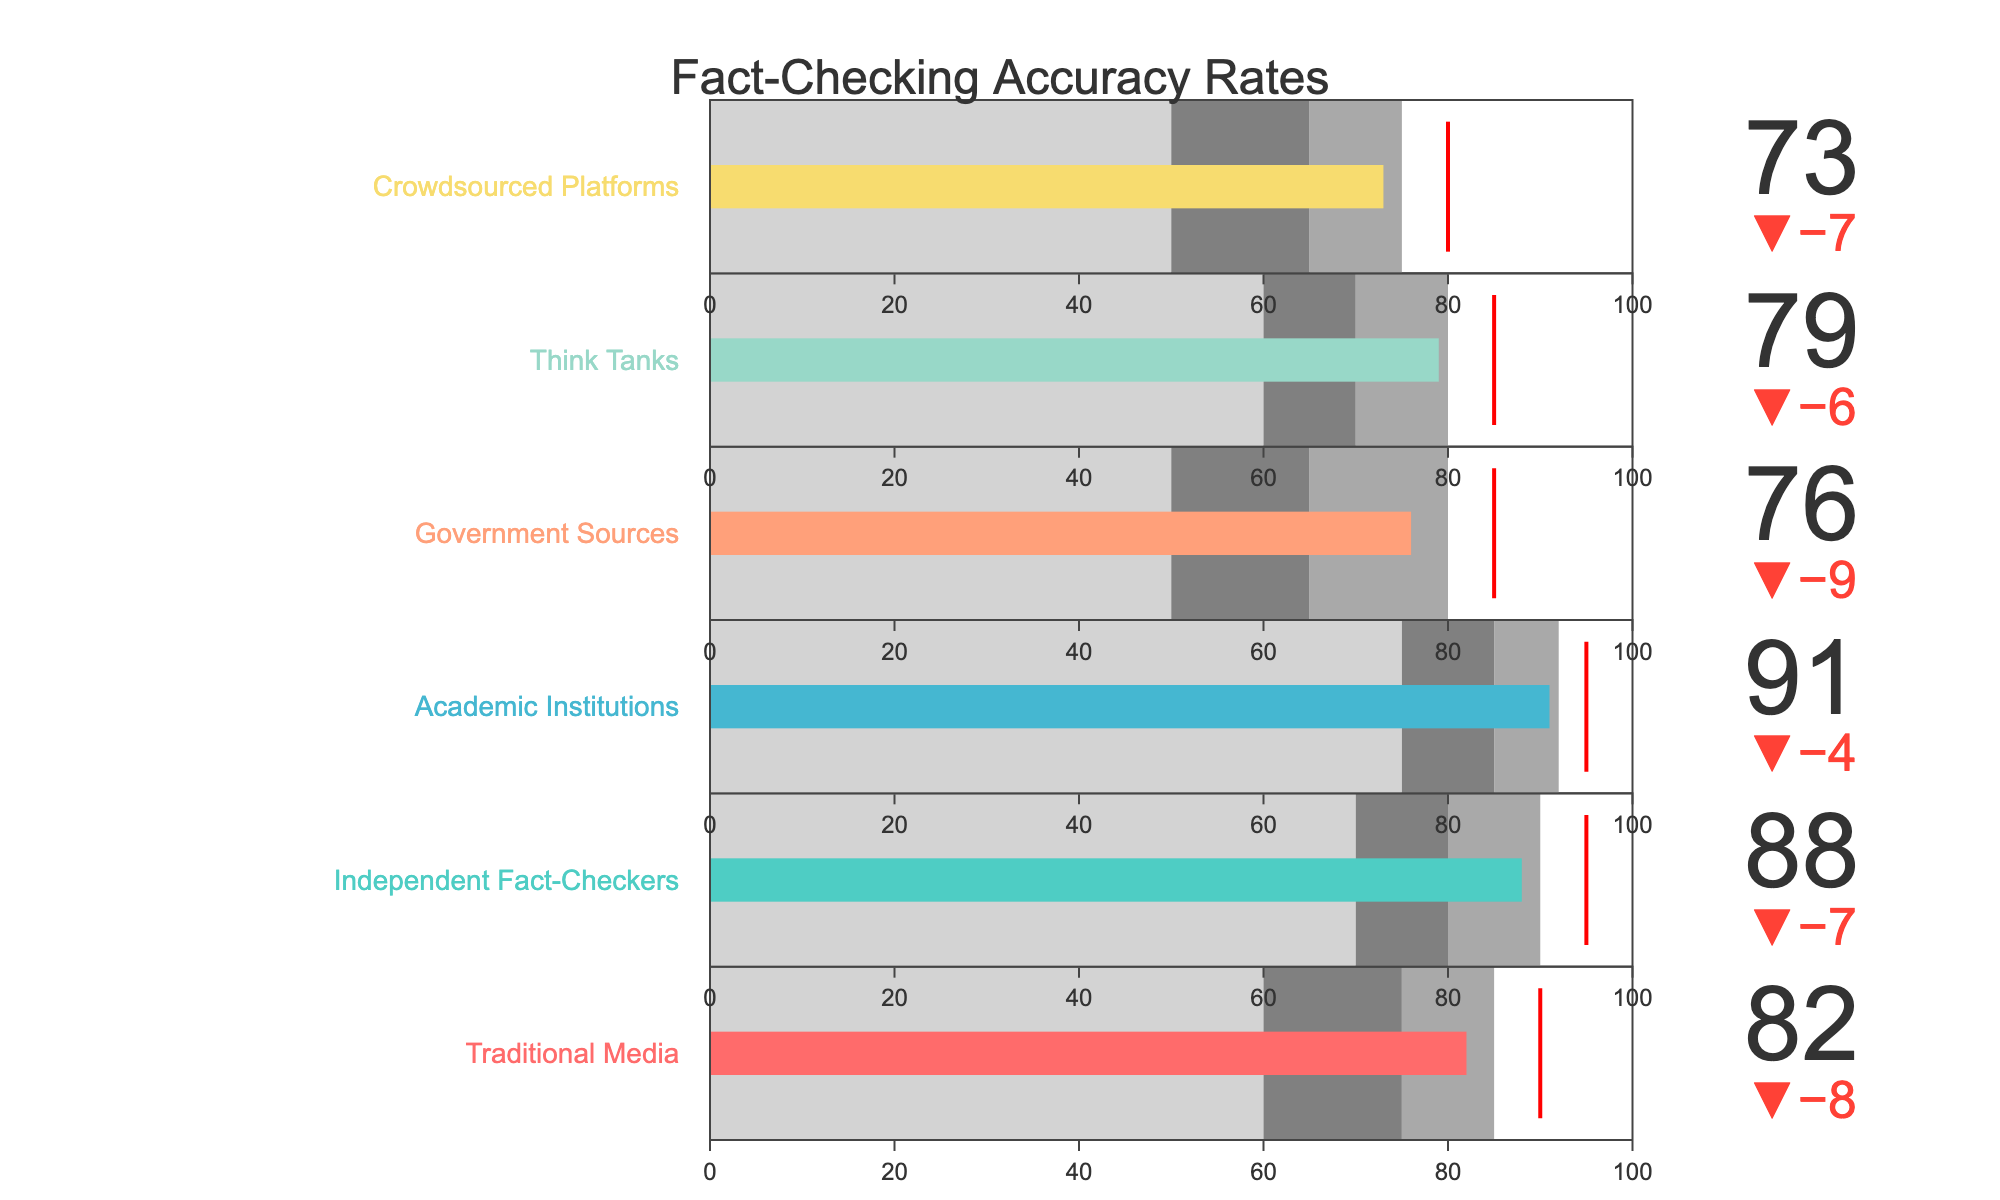What is the title of the chart? Look at the top of the figure, where the title is usually placed. The title often summarizes the content of the chart.
Answer: Fact-Checking Accuracy Rates Which category has the highest accuracy rate? Review the 'Actual' values for each category in the figure to determine which one is the highest. The 'Actual' value represents the accuracy rate.
Answer: Academic Institutions How many categories have an accuracy rate above 80? Examine the 'Actual' values of all the categories and count how many are greater than 80.
Answer: Four Which categories did not meet their target accuracy rates? Compare the 'Actual' values with the 'Target' values for each category. If the 'Actual' value is less than the 'Target' value, then it did not meet its target.
Answer: Traditional Media, Government Sources, Think Tanks, Crowdsourced Platforms Which category has the smallest difference between its actual and target rates? Calculate the difference between 'Actual' and 'Target' for each category and identify the smallest value.
Answer: Crowdsourced Platforms What is the accuracy range covered by Government Sources? Identify the three color blocks representing different accuracy ranges and their values for Government Sources, listed as Range1, Range2, and Range3.
Answer: 50-65, 65-80, 80-100 How many categories have their Actual value within their second accuracy range (Range2)? Check each category's 'Actual' value to see if it falls between Range1 and Range2. Count how many categories meet this criterion.
Answer: Two Which source type has the most significant gap between its actual accuracy rate and target? Calculate the difference between 'Actual' and 'Target' for each category, then identify the largest gap.
Answer: Independent Fact-Checkers What color is used for the Academic Institutions' bar in the bullet chart? Look for the bar color associated with the Academic Institutions category in the chart.
Answer: Light purple 